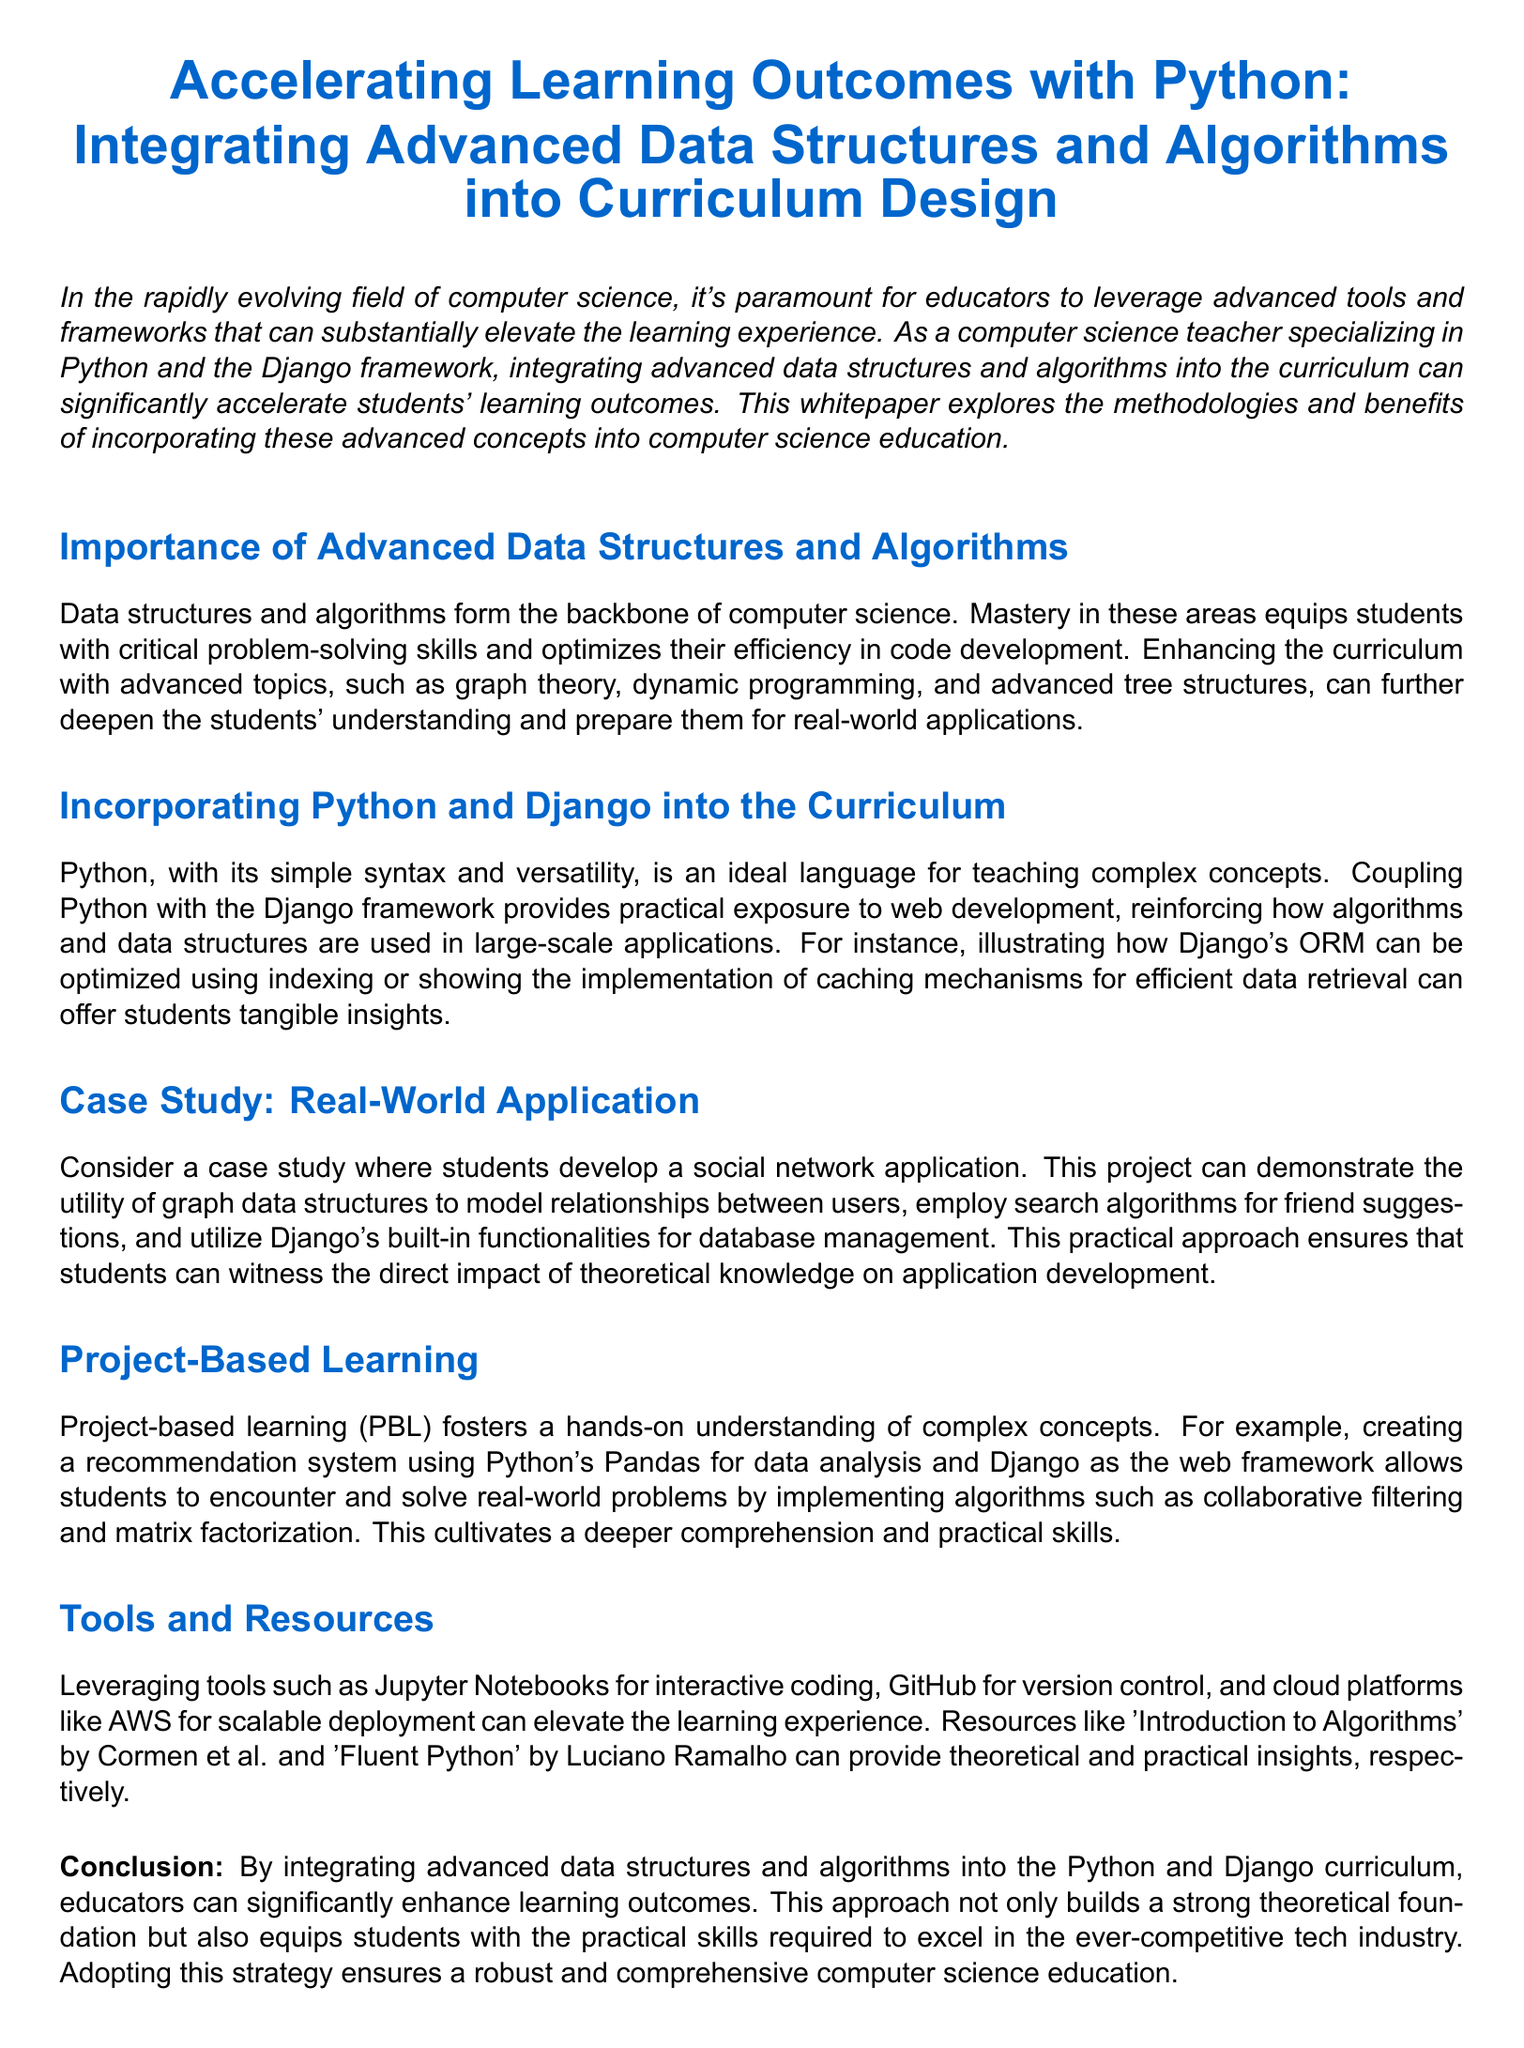What is the focus of the whitepaper? The focus of the whitepaper is on enhancing the learning experience by integrating advanced data structures and algorithms into the curriculum.
Answer: Enhancing the learning experience What language is primarily discussed for teaching? The language primarily discussed for teaching complex concepts is Python.
Answer: Python What framework is mentioned alongside Python? The framework mentioned alongside Python is Django.
Answer: Django What project type is used as a case study in the document? The project type used as a case study in the document is a social network application.
Answer: Social network application Which learning method is emphasized for understanding complex concepts? The learning method emphasized for understanding complex concepts is project-based learning.
Answer: Project-based learning What is one of the tools suggested for interactive coding? One of the tools suggested for interactive coding is Jupyter Notebooks.
Answer: Jupyter Notebooks Who are the authors of the suggested resource 'Introduction to Algorithms'? The authors of the suggested resource 'Introduction to Algorithms' are Cormen et al.
Answer: Cormen et al What algorithm technique is mentioned for recommendation systems? The algorithm technique mentioned for recommendation systems is collaborative filtering.
Answer: Collaborative filtering What is the ultimate goal of integrating advanced topics into the curriculum? The ultimate goal of integrating advanced topics into the curriculum is to enhance learning outcomes.
Answer: Enhance learning outcomes 